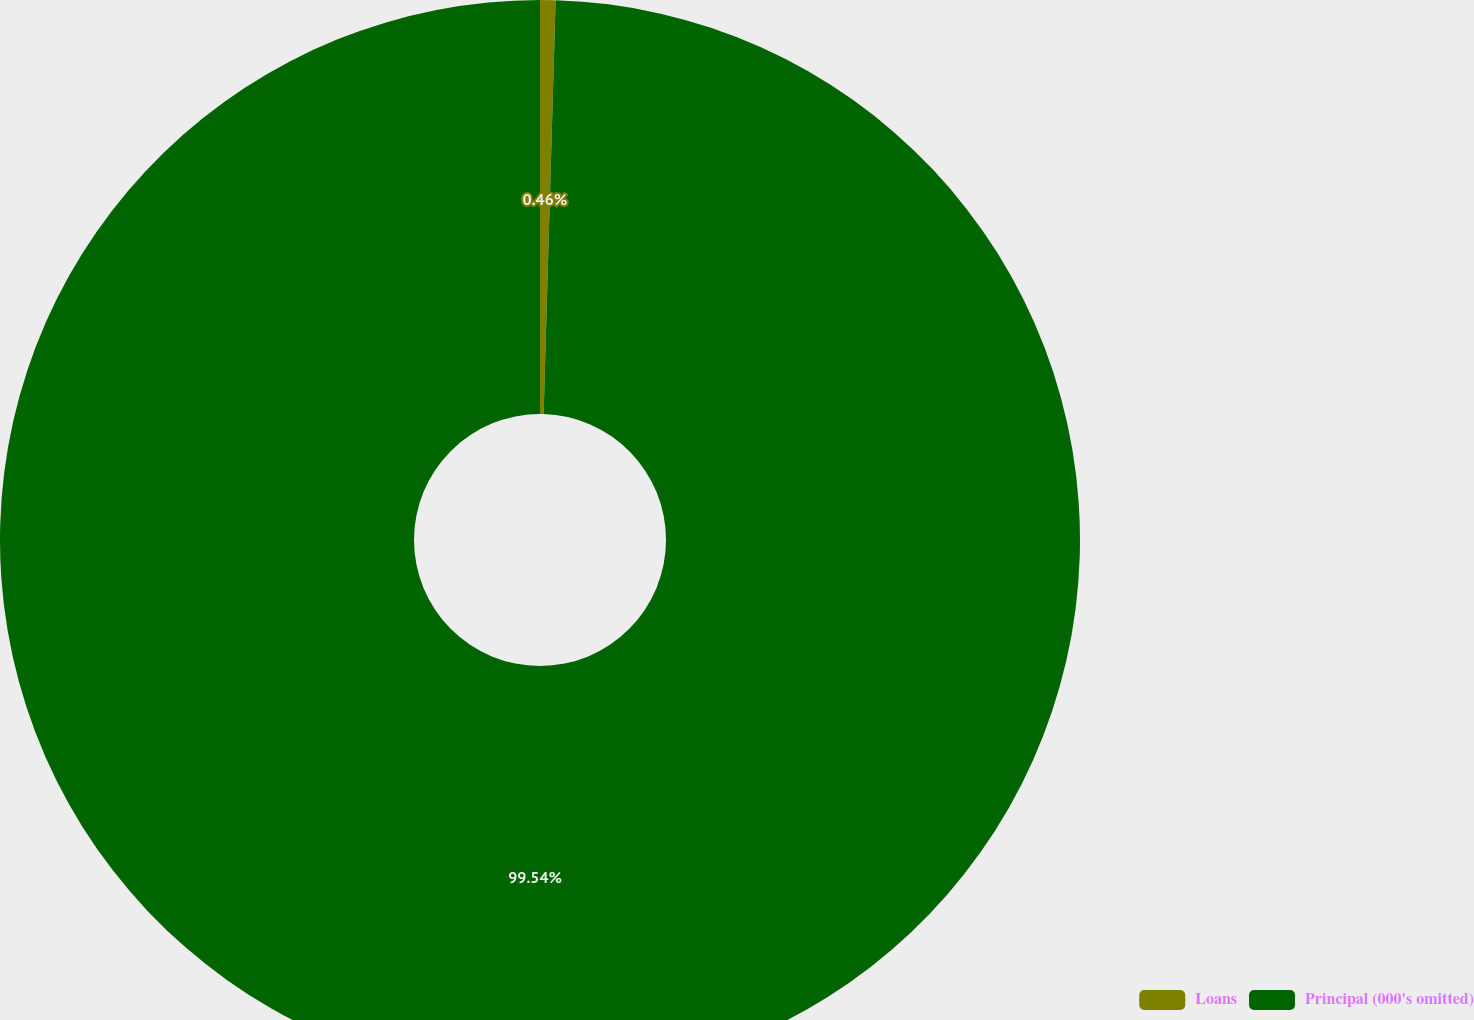Convert chart to OTSL. <chart><loc_0><loc_0><loc_500><loc_500><pie_chart><fcel>Loans<fcel>Principal (000's omitted)<nl><fcel>0.46%<fcel>99.54%<nl></chart> 